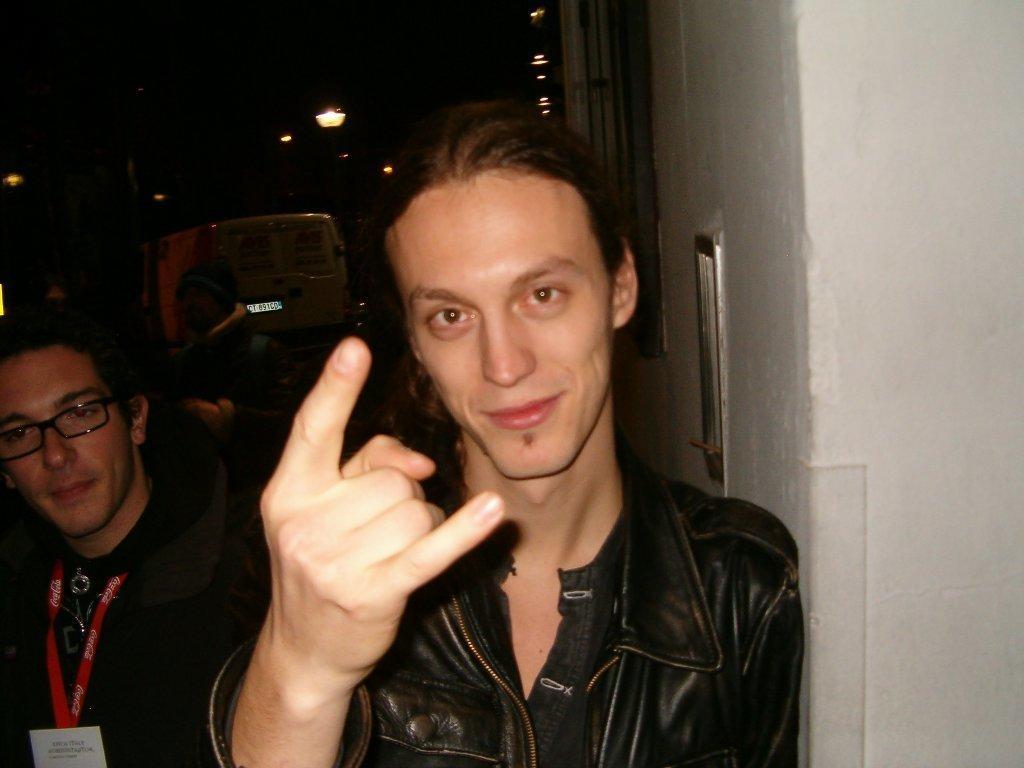In one or two sentences, can you explain what this image depicts? A man is showing his fingers, he wore a black color coat. 